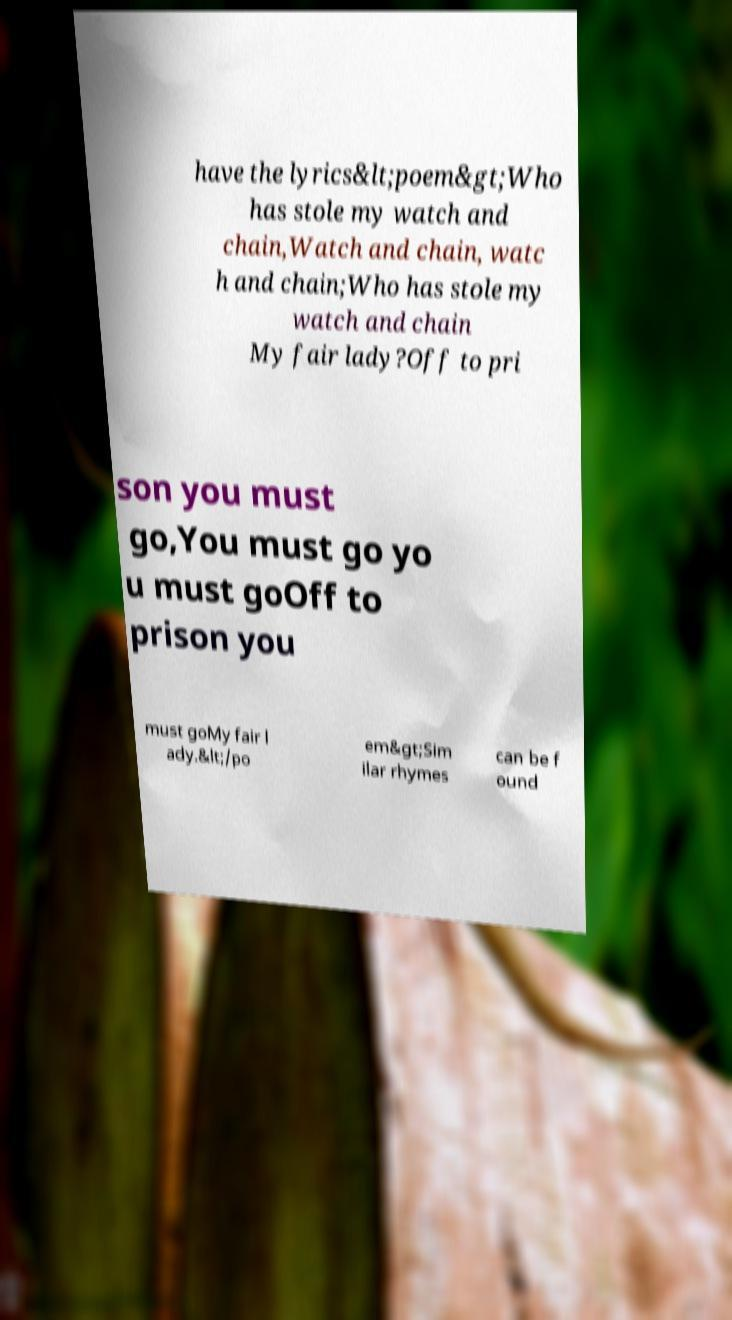I need the written content from this picture converted into text. Can you do that? have the lyrics&lt;poem&gt;Who has stole my watch and chain,Watch and chain, watc h and chain;Who has stole my watch and chain My fair lady?Off to pri son you must go,You must go yo u must goOff to prison you must goMy fair l ady.&lt;/po em&gt;Sim ilar rhymes can be f ound 